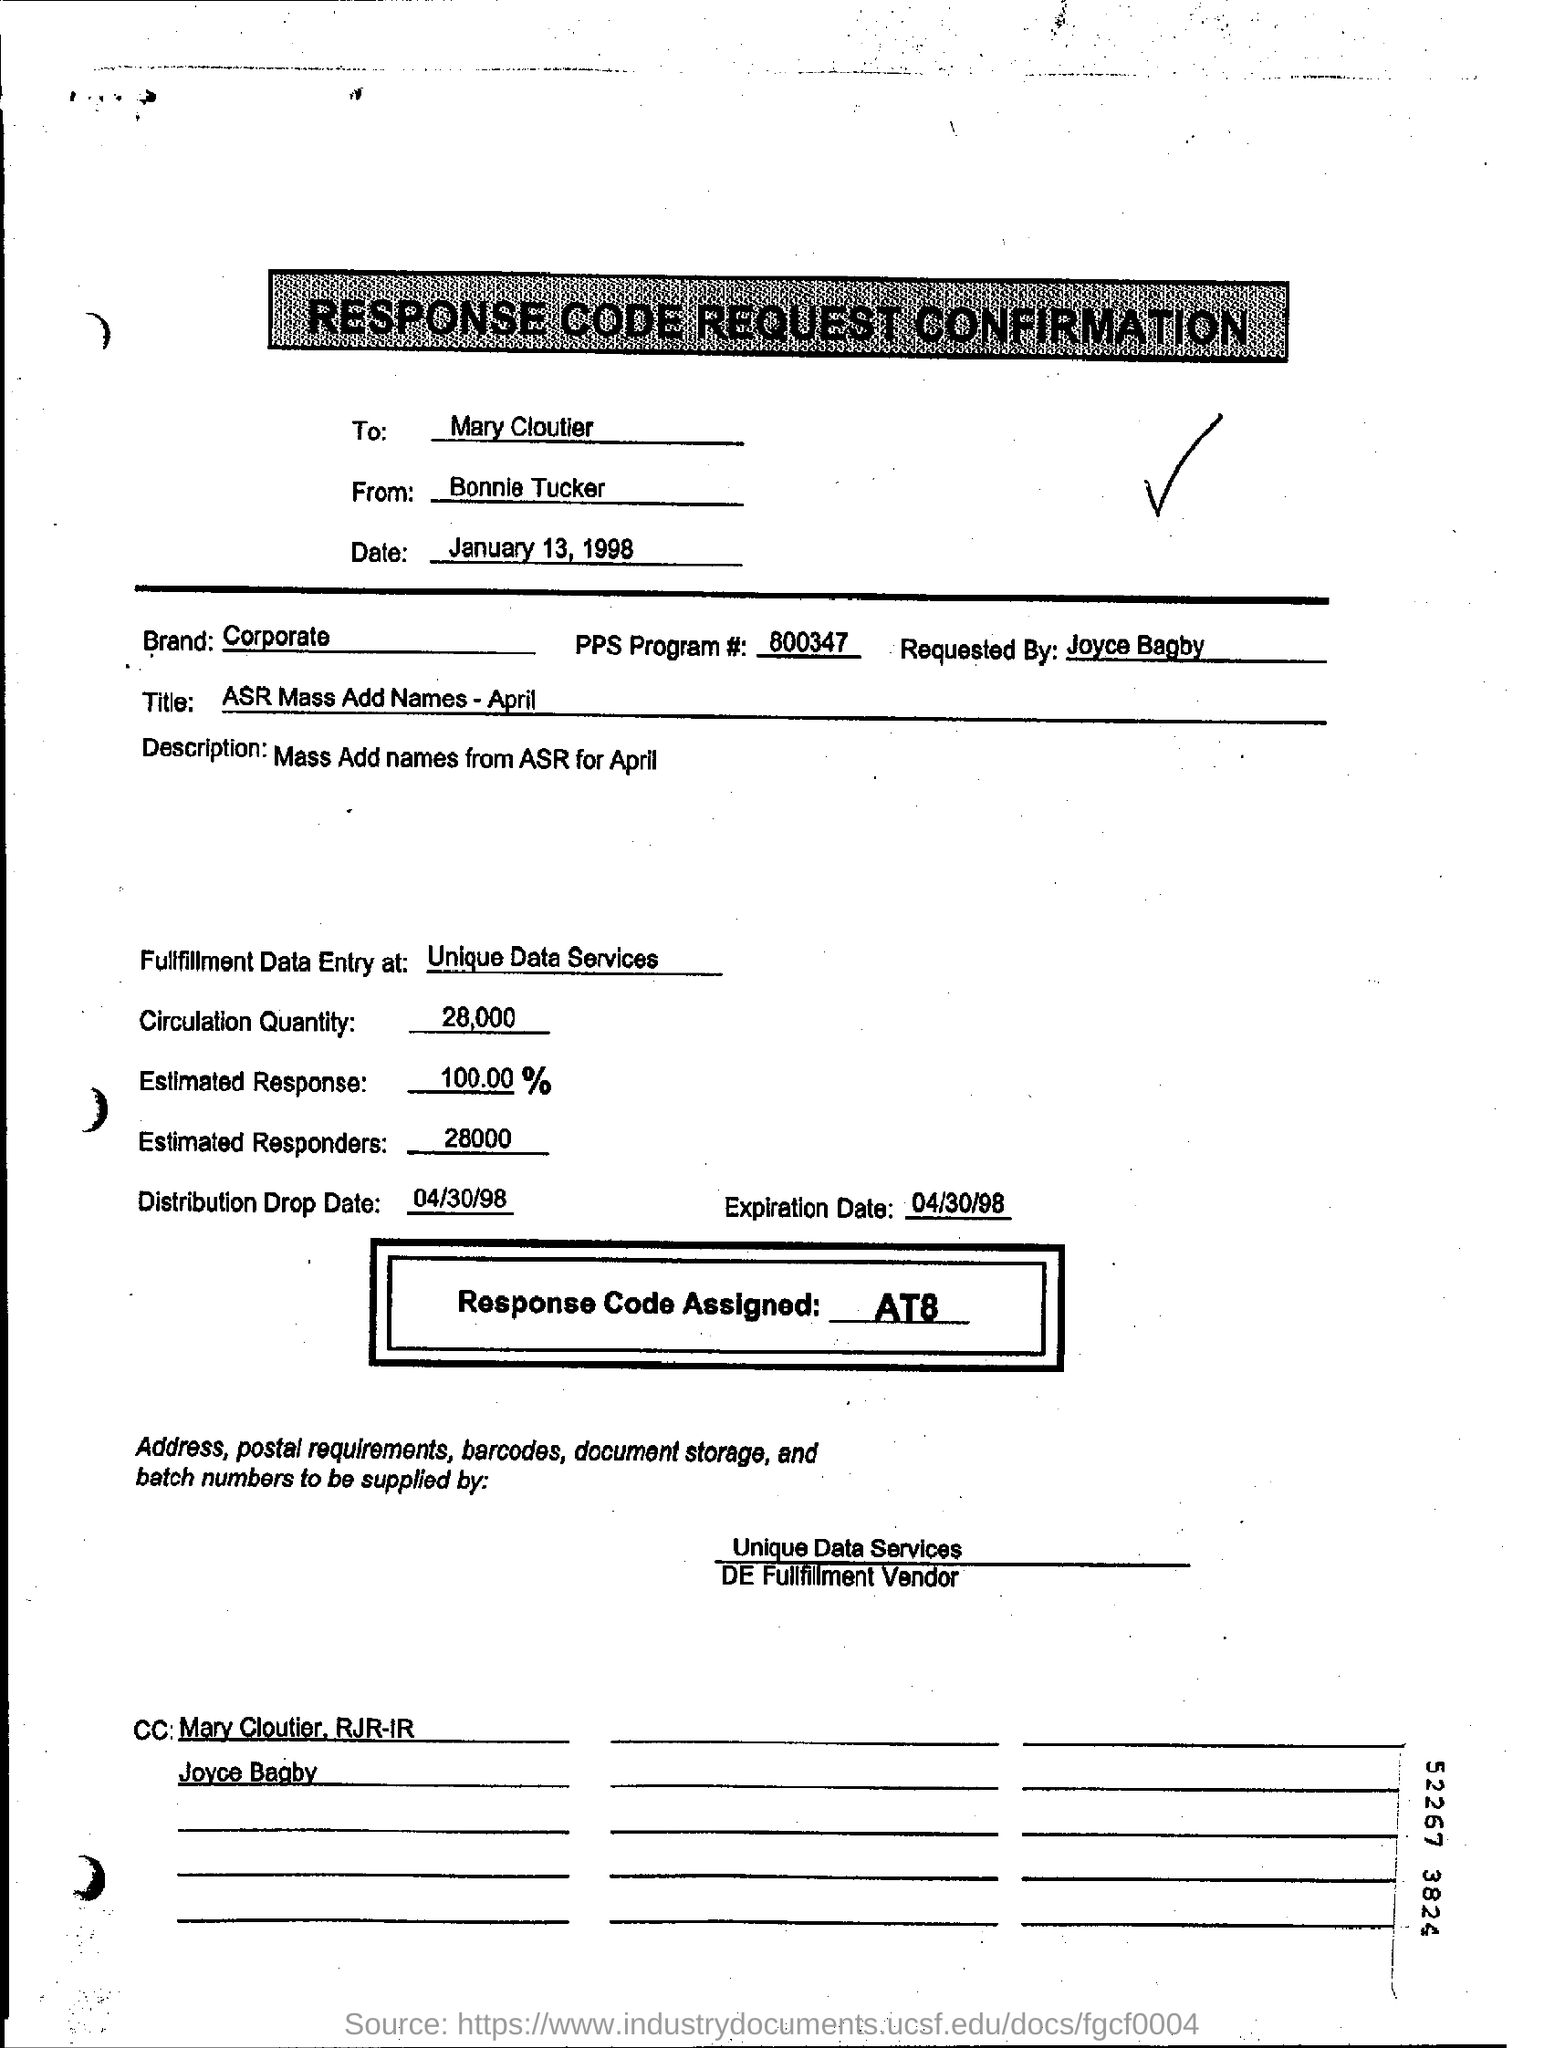What is "distribution drop date"? The term 'distribution drop date' typically refers to the scheduled date on which materials, products, or information are distributed. In the context of the image, which appears to be a document related to a mass addition of names for a corporate program taking place in April 1998, the distribution drop date is April 30, 1998. This is the date by which the materials (likely related to the addition of names) should be fully distributed. 